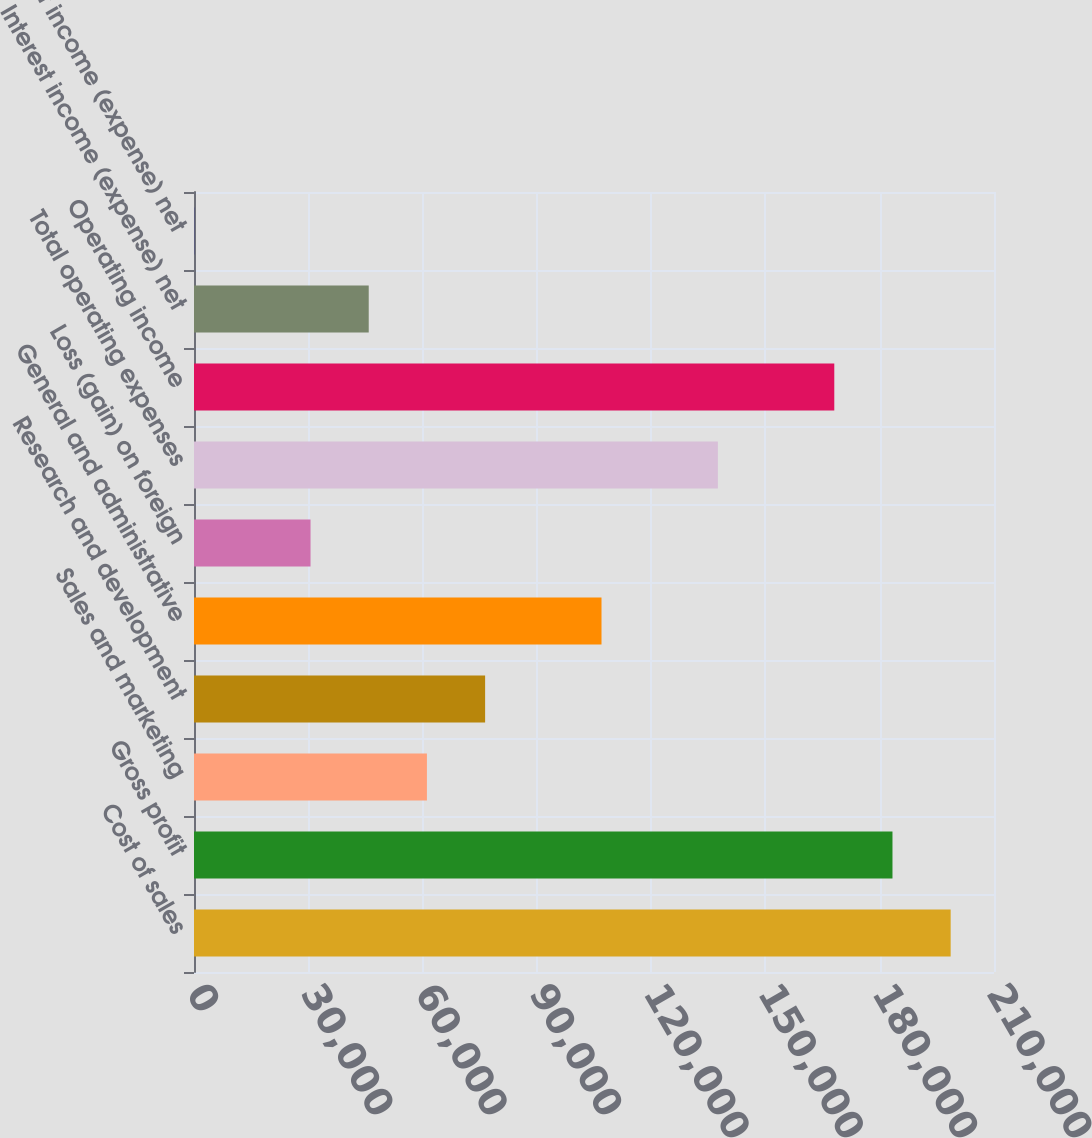Convert chart to OTSL. <chart><loc_0><loc_0><loc_500><loc_500><bar_chart><fcel>Cost of sales<fcel>Gross profit<fcel>Sales and marketing<fcel>Research and development<fcel>General and administrative<fcel>Loss (gain) on foreign<fcel>Total operating expenses<fcel>Operating income<fcel>Interest income (expense) net<fcel>Other income (expense) net<nl><fcel>198626<fcel>183350<fcel>61142.6<fcel>76418.5<fcel>106970<fcel>30590.8<fcel>137522<fcel>168074<fcel>45866.7<fcel>39<nl></chart> 